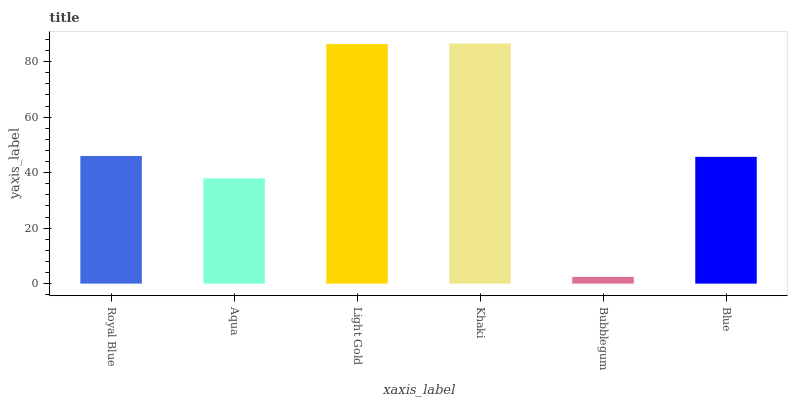Is Bubblegum the minimum?
Answer yes or no. Yes. Is Khaki the maximum?
Answer yes or no. Yes. Is Aqua the minimum?
Answer yes or no. No. Is Aqua the maximum?
Answer yes or no. No. Is Royal Blue greater than Aqua?
Answer yes or no. Yes. Is Aqua less than Royal Blue?
Answer yes or no. Yes. Is Aqua greater than Royal Blue?
Answer yes or no. No. Is Royal Blue less than Aqua?
Answer yes or no. No. Is Royal Blue the high median?
Answer yes or no. Yes. Is Blue the low median?
Answer yes or no. Yes. Is Blue the high median?
Answer yes or no. No. Is Royal Blue the low median?
Answer yes or no. No. 